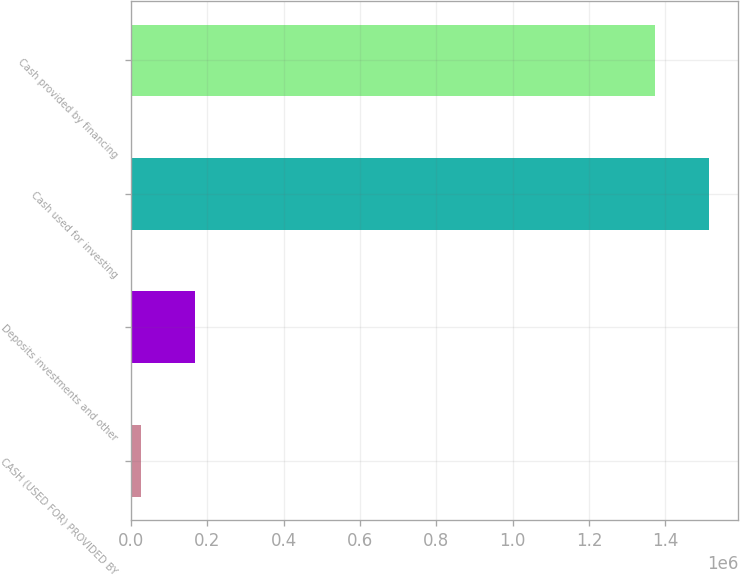Convert chart to OTSL. <chart><loc_0><loc_0><loc_500><loc_500><bar_chart><fcel>CASH (USED FOR) PROVIDED BY<fcel>Deposits investments and other<fcel>Cash used for investing<fcel>Cash provided by financing<nl><fcel>26070<fcel>167993<fcel>1.51508e+06<fcel>1.37315e+06<nl></chart> 